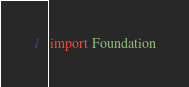Convert code to text. <code><loc_0><loc_0><loc_500><loc_500><_Swift_>import Foundation
</code> 